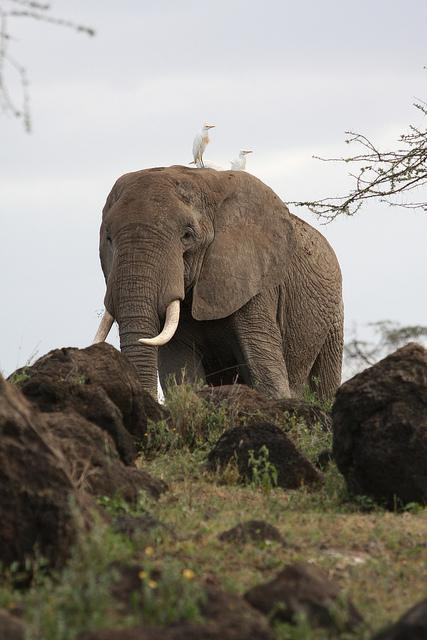What is in front of the elephant's tusks? rocks 